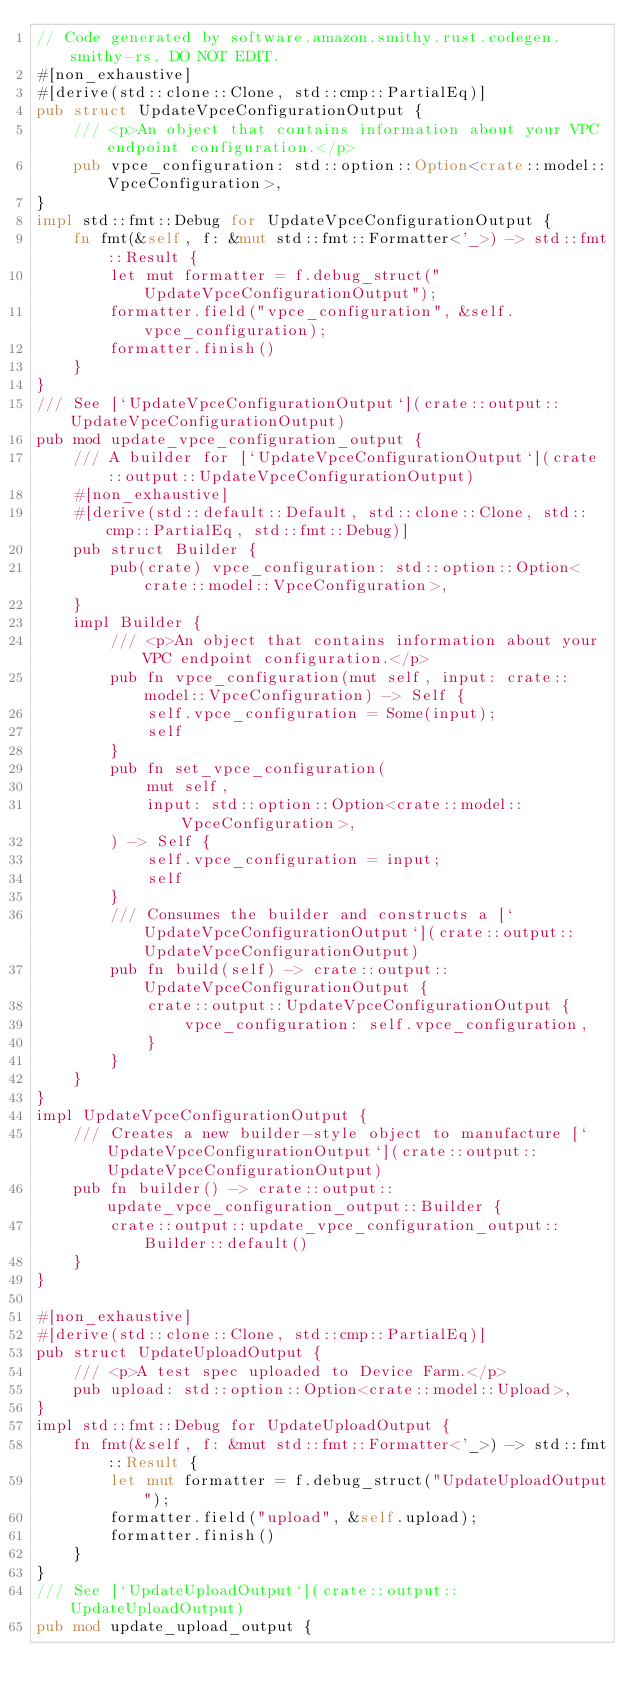<code> <loc_0><loc_0><loc_500><loc_500><_Rust_>// Code generated by software.amazon.smithy.rust.codegen.smithy-rs. DO NOT EDIT.
#[non_exhaustive]
#[derive(std::clone::Clone, std::cmp::PartialEq)]
pub struct UpdateVpceConfigurationOutput {
    /// <p>An object that contains information about your VPC endpoint configuration.</p>
    pub vpce_configuration: std::option::Option<crate::model::VpceConfiguration>,
}
impl std::fmt::Debug for UpdateVpceConfigurationOutput {
    fn fmt(&self, f: &mut std::fmt::Formatter<'_>) -> std::fmt::Result {
        let mut formatter = f.debug_struct("UpdateVpceConfigurationOutput");
        formatter.field("vpce_configuration", &self.vpce_configuration);
        formatter.finish()
    }
}
/// See [`UpdateVpceConfigurationOutput`](crate::output::UpdateVpceConfigurationOutput)
pub mod update_vpce_configuration_output {
    /// A builder for [`UpdateVpceConfigurationOutput`](crate::output::UpdateVpceConfigurationOutput)
    #[non_exhaustive]
    #[derive(std::default::Default, std::clone::Clone, std::cmp::PartialEq, std::fmt::Debug)]
    pub struct Builder {
        pub(crate) vpce_configuration: std::option::Option<crate::model::VpceConfiguration>,
    }
    impl Builder {
        /// <p>An object that contains information about your VPC endpoint configuration.</p>
        pub fn vpce_configuration(mut self, input: crate::model::VpceConfiguration) -> Self {
            self.vpce_configuration = Some(input);
            self
        }
        pub fn set_vpce_configuration(
            mut self,
            input: std::option::Option<crate::model::VpceConfiguration>,
        ) -> Self {
            self.vpce_configuration = input;
            self
        }
        /// Consumes the builder and constructs a [`UpdateVpceConfigurationOutput`](crate::output::UpdateVpceConfigurationOutput)
        pub fn build(self) -> crate::output::UpdateVpceConfigurationOutput {
            crate::output::UpdateVpceConfigurationOutput {
                vpce_configuration: self.vpce_configuration,
            }
        }
    }
}
impl UpdateVpceConfigurationOutput {
    /// Creates a new builder-style object to manufacture [`UpdateVpceConfigurationOutput`](crate::output::UpdateVpceConfigurationOutput)
    pub fn builder() -> crate::output::update_vpce_configuration_output::Builder {
        crate::output::update_vpce_configuration_output::Builder::default()
    }
}

#[non_exhaustive]
#[derive(std::clone::Clone, std::cmp::PartialEq)]
pub struct UpdateUploadOutput {
    /// <p>A test spec uploaded to Device Farm.</p>
    pub upload: std::option::Option<crate::model::Upload>,
}
impl std::fmt::Debug for UpdateUploadOutput {
    fn fmt(&self, f: &mut std::fmt::Formatter<'_>) -> std::fmt::Result {
        let mut formatter = f.debug_struct("UpdateUploadOutput");
        formatter.field("upload", &self.upload);
        formatter.finish()
    }
}
/// See [`UpdateUploadOutput`](crate::output::UpdateUploadOutput)
pub mod update_upload_output {</code> 